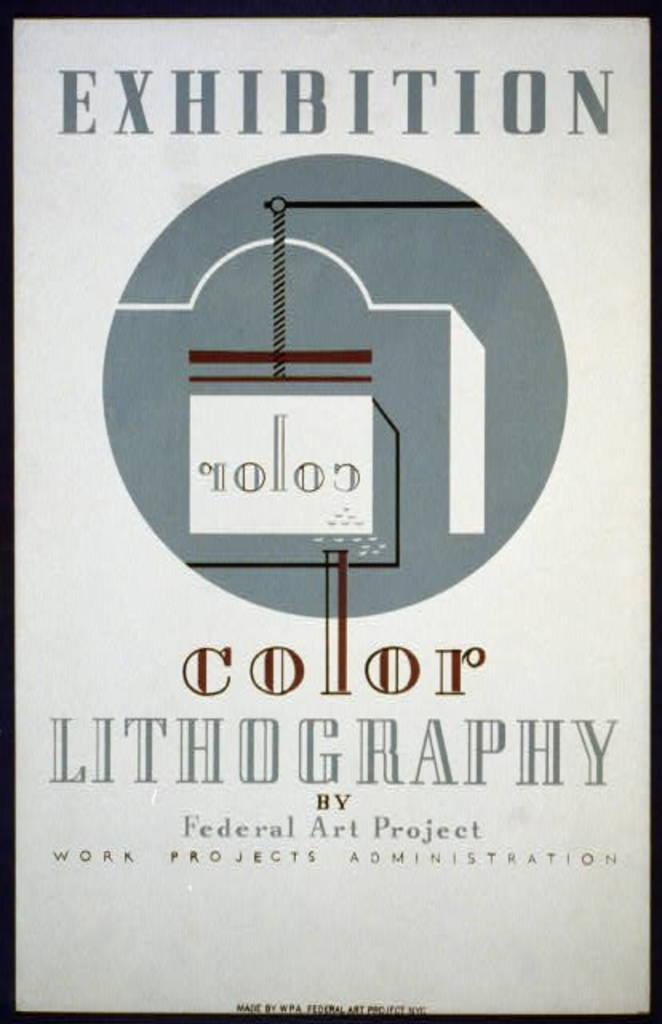<image>
Give a short and clear explanation of the subsequent image. A sign about color lithography being a federal art project. 